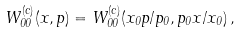Convert formula to latex. <formula><loc_0><loc_0><loc_500><loc_500>W ^ { ( c ) } _ { 0 0 } ( x , p ) = W ^ { ( c ) } _ { 0 0 } ( x _ { 0 } p / p _ { 0 } , p _ { 0 } x / x _ { 0 } ) \, ,</formula> 